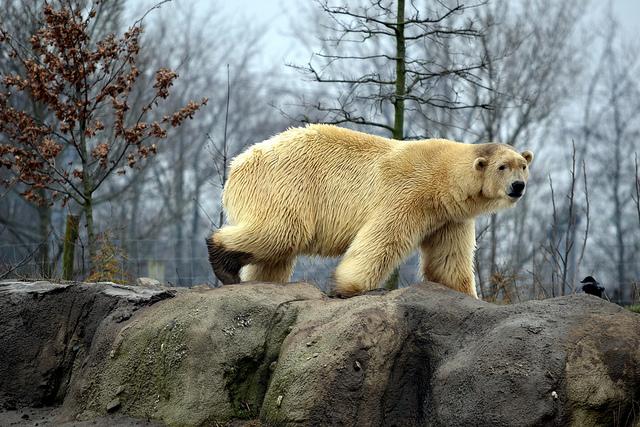What season is this picture taken in?
Be succinct. Winter. What kind of bear is this?
Short answer required. Polar. Is the bear clean?
Short answer required. No. What color are the bears?
Write a very short answer. White. Is this animal in its native habitat?
Keep it brief. No. 